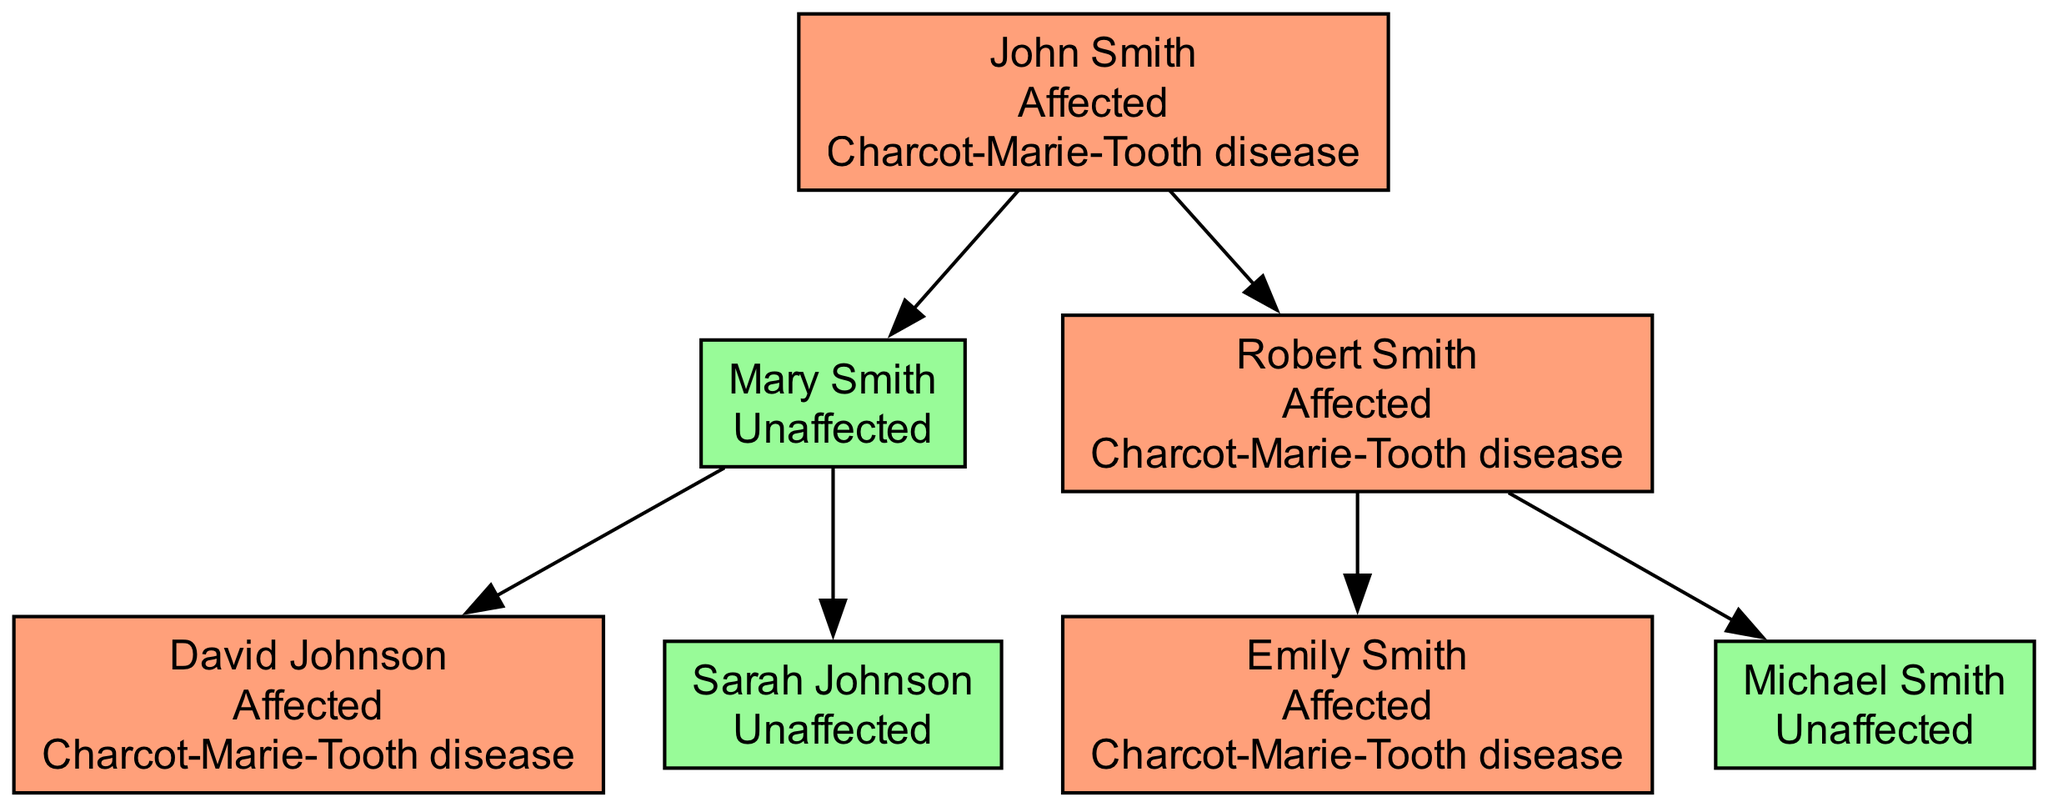What condition does John Smith have? The diagram labels John Smith as "Affected" and indicates that he has "Charcot-Marie-Tooth disease."
Answer: Charcot-Marie-Tooth disease How many children does Robert Smith have? Robert Smith has two children shown under his node in the diagram: Emily Smith and Michael Smith.
Answer: 2 Who is the parent of David Johnson? David Johnson is a child of Mary Smith, shown in the diagram with a direct line connecting them, indicating Mary is the parent.
Answer: Mary Smith What is the status of Michael Smith? The diagram notes Michael Smith as "Unaffected," meaning he does not have the condition shown for other family members.
Answer: Unaffected Which family member shows the condition in the second generation? In the second generation, David Johnson and Emily Smith are both affected, per the diagram.
Answer: David Johnson, Emily Smith Is there any unaffected individual among the children of John Smith? Mary Smith and Michael Smith are both shown as unaffected, providing evidence of unaffected individuals among John's children.
Answer: Yes How many affected members are there in the family tree? Counting John Smith, Robert Smith, David Johnson, and Emily Smith reveals four affected individuals in total.
Answer: 4 What is the relationship between Sarah Johnson and John Smith? Sarah Johnson is the granddaughter of John Smith, as she is the child of Mary Smith, who is John's daughter.
Answer: Granddaughter Which generation contains the most number of affected individuals? The first generation contains John Smith and Robert Smith, both affected, while the second generation has David Johnson and Emily Smith. Hence, the first generation has two affected individuals.
Answer: First generation 